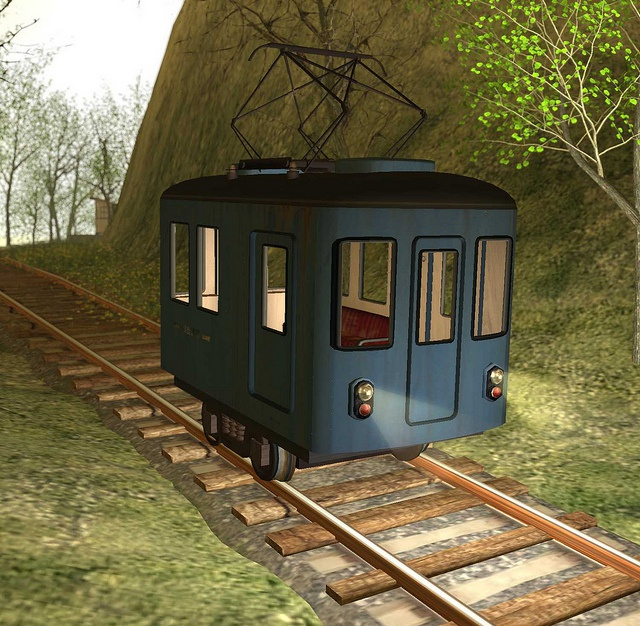Describe the objects in this image and their specific colors. I can see a train in beige, black, gray, purple, and darkgreen tones in this image. 